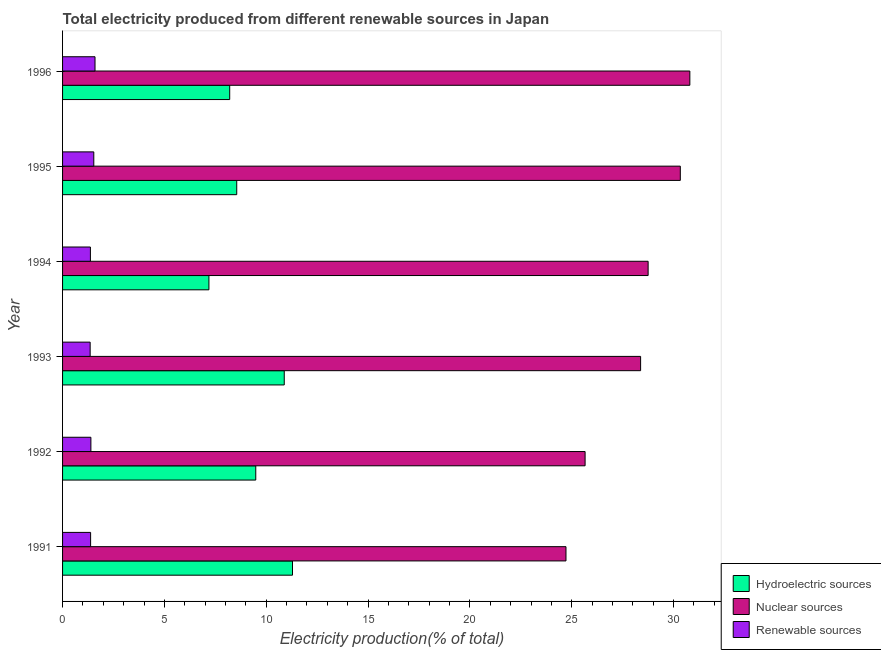How many different coloured bars are there?
Your response must be concise. 3. How many groups of bars are there?
Your response must be concise. 6. What is the label of the 4th group of bars from the top?
Keep it short and to the point. 1993. What is the percentage of electricity produced by hydroelectric sources in 1996?
Your answer should be compact. 8.21. Across all years, what is the maximum percentage of electricity produced by renewable sources?
Provide a short and direct response. 1.59. Across all years, what is the minimum percentage of electricity produced by nuclear sources?
Offer a terse response. 24.72. What is the total percentage of electricity produced by nuclear sources in the graph?
Your answer should be compact. 168.63. What is the difference between the percentage of electricity produced by renewable sources in 1992 and that in 1994?
Your answer should be compact. 0.02. What is the difference between the percentage of electricity produced by nuclear sources in 1996 and the percentage of electricity produced by hydroelectric sources in 1994?
Keep it short and to the point. 23.61. What is the average percentage of electricity produced by renewable sources per year?
Keep it short and to the point. 1.44. In the year 1996, what is the difference between the percentage of electricity produced by renewable sources and percentage of electricity produced by nuclear sources?
Ensure brevity in your answer.  -29.2. What is the ratio of the percentage of electricity produced by hydroelectric sources in 1994 to that in 1996?
Ensure brevity in your answer.  0.88. Is the percentage of electricity produced by hydroelectric sources in 1992 less than that in 1994?
Offer a very short reply. No. Is the difference between the percentage of electricity produced by hydroelectric sources in 1993 and 1996 greater than the difference between the percentage of electricity produced by nuclear sources in 1993 and 1996?
Your answer should be very brief. Yes. What is the difference between the highest and the second highest percentage of electricity produced by hydroelectric sources?
Provide a succinct answer. 0.41. In how many years, is the percentage of electricity produced by hydroelectric sources greater than the average percentage of electricity produced by hydroelectric sources taken over all years?
Provide a short and direct response. 3. Is the sum of the percentage of electricity produced by nuclear sources in 1993 and 1995 greater than the maximum percentage of electricity produced by renewable sources across all years?
Your response must be concise. Yes. What does the 3rd bar from the top in 1993 represents?
Your answer should be compact. Hydroelectric sources. What does the 1st bar from the bottom in 1995 represents?
Keep it short and to the point. Hydroelectric sources. Is it the case that in every year, the sum of the percentage of electricity produced by hydroelectric sources and percentage of electricity produced by nuclear sources is greater than the percentage of electricity produced by renewable sources?
Your answer should be compact. Yes. How many bars are there?
Make the answer very short. 18. Are all the bars in the graph horizontal?
Provide a short and direct response. Yes. What is the difference between two consecutive major ticks on the X-axis?
Keep it short and to the point. 5. Are the values on the major ticks of X-axis written in scientific E-notation?
Ensure brevity in your answer.  No. Does the graph contain any zero values?
Your response must be concise. No. Does the graph contain grids?
Offer a terse response. No. Where does the legend appear in the graph?
Give a very brief answer. Bottom right. How are the legend labels stacked?
Your response must be concise. Vertical. What is the title of the graph?
Your response must be concise. Total electricity produced from different renewable sources in Japan. What is the label or title of the X-axis?
Make the answer very short. Electricity production(% of total). What is the Electricity production(% of total) of Hydroelectric sources in 1991?
Your response must be concise. 11.29. What is the Electricity production(% of total) in Nuclear sources in 1991?
Your response must be concise. 24.72. What is the Electricity production(% of total) of Renewable sources in 1991?
Make the answer very short. 1.38. What is the Electricity production(% of total) of Hydroelectric sources in 1992?
Your response must be concise. 9.49. What is the Electricity production(% of total) of Nuclear sources in 1992?
Your answer should be compact. 25.65. What is the Electricity production(% of total) in Renewable sources in 1992?
Keep it short and to the point. 1.39. What is the Electricity production(% of total) of Hydroelectric sources in 1993?
Ensure brevity in your answer.  10.88. What is the Electricity production(% of total) of Nuclear sources in 1993?
Keep it short and to the point. 28.38. What is the Electricity production(% of total) of Renewable sources in 1993?
Offer a terse response. 1.35. What is the Electricity production(% of total) in Hydroelectric sources in 1994?
Your response must be concise. 7.19. What is the Electricity production(% of total) of Nuclear sources in 1994?
Keep it short and to the point. 28.75. What is the Electricity production(% of total) in Renewable sources in 1994?
Provide a short and direct response. 1.37. What is the Electricity production(% of total) of Hydroelectric sources in 1995?
Offer a terse response. 8.55. What is the Electricity production(% of total) of Nuclear sources in 1995?
Offer a terse response. 30.33. What is the Electricity production(% of total) in Renewable sources in 1995?
Ensure brevity in your answer.  1.53. What is the Electricity production(% of total) in Hydroelectric sources in 1996?
Provide a short and direct response. 8.21. What is the Electricity production(% of total) of Nuclear sources in 1996?
Give a very brief answer. 30.8. What is the Electricity production(% of total) of Renewable sources in 1996?
Your answer should be compact. 1.59. Across all years, what is the maximum Electricity production(% of total) in Hydroelectric sources?
Offer a very short reply. 11.29. Across all years, what is the maximum Electricity production(% of total) in Nuclear sources?
Provide a succinct answer. 30.8. Across all years, what is the maximum Electricity production(% of total) in Renewable sources?
Your answer should be very brief. 1.59. Across all years, what is the minimum Electricity production(% of total) of Hydroelectric sources?
Offer a very short reply. 7.19. Across all years, what is the minimum Electricity production(% of total) of Nuclear sources?
Provide a short and direct response. 24.72. Across all years, what is the minimum Electricity production(% of total) in Renewable sources?
Your answer should be compact. 1.35. What is the total Electricity production(% of total) of Hydroelectric sources in the graph?
Your response must be concise. 55.6. What is the total Electricity production(% of total) of Nuclear sources in the graph?
Offer a very short reply. 168.63. What is the total Electricity production(% of total) of Renewable sources in the graph?
Offer a very short reply. 8.62. What is the difference between the Electricity production(% of total) in Hydroelectric sources in 1991 and that in 1992?
Your answer should be compact. 1.8. What is the difference between the Electricity production(% of total) in Nuclear sources in 1991 and that in 1992?
Provide a succinct answer. -0.94. What is the difference between the Electricity production(% of total) of Renewable sources in 1991 and that in 1992?
Ensure brevity in your answer.  -0.01. What is the difference between the Electricity production(% of total) of Hydroelectric sources in 1991 and that in 1993?
Keep it short and to the point. 0.41. What is the difference between the Electricity production(% of total) in Nuclear sources in 1991 and that in 1993?
Make the answer very short. -3.66. What is the difference between the Electricity production(% of total) of Renewable sources in 1991 and that in 1993?
Provide a short and direct response. 0.02. What is the difference between the Electricity production(% of total) in Hydroelectric sources in 1991 and that in 1994?
Keep it short and to the point. 4.1. What is the difference between the Electricity production(% of total) in Nuclear sources in 1991 and that in 1994?
Offer a very short reply. -4.03. What is the difference between the Electricity production(% of total) in Renewable sources in 1991 and that in 1994?
Provide a short and direct response. 0.01. What is the difference between the Electricity production(% of total) of Hydroelectric sources in 1991 and that in 1995?
Your response must be concise. 2.74. What is the difference between the Electricity production(% of total) in Nuclear sources in 1991 and that in 1995?
Provide a short and direct response. -5.61. What is the difference between the Electricity production(% of total) in Renewable sources in 1991 and that in 1995?
Keep it short and to the point. -0.16. What is the difference between the Electricity production(% of total) of Hydroelectric sources in 1991 and that in 1996?
Your answer should be compact. 3.08. What is the difference between the Electricity production(% of total) in Nuclear sources in 1991 and that in 1996?
Give a very brief answer. -6.08. What is the difference between the Electricity production(% of total) of Renewable sources in 1991 and that in 1996?
Provide a short and direct response. -0.22. What is the difference between the Electricity production(% of total) of Hydroelectric sources in 1992 and that in 1993?
Ensure brevity in your answer.  -1.4. What is the difference between the Electricity production(% of total) of Nuclear sources in 1992 and that in 1993?
Your answer should be very brief. -2.73. What is the difference between the Electricity production(% of total) in Renewable sources in 1992 and that in 1993?
Ensure brevity in your answer.  0.04. What is the difference between the Electricity production(% of total) in Hydroelectric sources in 1992 and that in 1994?
Ensure brevity in your answer.  2.3. What is the difference between the Electricity production(% of total) of Nuclear sources in 1992 and that in 1994?
Your answer should be very brief. -3.09. What is the difference between the Electricity production(% of total) of Renewable sources in 1992 and that in 1994?
Make the answer very short. 0.02. What is the difference between the Electricity production(% of total) in Hydroelectric sources in 1992 and that in 1995?
Make the answer very short. 0.93. What is the difference between the Electricity production(% of total) of Nuclear sources in 1992 and that in 1995?
Give a very brief answer. -4.67. What is the difference between the Electricity production(% of total) in Renewable sources in 1992 and that in 1995?
Offer a very short reply. -0.14. What is the difference between the Electricity production(% of total) of Hydroelectric sources in 1992 and that in 1996?
Make the answer very short. 1.28. What is the difference between the Electricity production(% of total) of Nuclear sources in 1992 and that in 1996?
Offer a very short reply. -5.14. What is the difference between the Electricity production(% of total) of Renewable sources in 1992 and that in 1996?
Provide a short and direct response. -0.2. What is the difference between the Electricity production(% of total) in Hydroelectric sources in 1993 and that in 1994?
Make the answer very short. 3.7. What is the difference between the Electricity production(% of total) of Nuclear sources in 1993 and that in 1994?
Offer a terse response. -0.37. What is the difference between the Electricity production(% of total) of Renewable sources in 1993 and that in 1994?
Your answer should be very brief. -0.01. What is the difference between the Electricity production(% of total) of Hydroelectric sources in 1993 and that in 1995?
Your answer should be very brief. 2.33. What is the difference between the Electricity production(% of total) in Nuclear sources in 1993 and that in 1995?
Offer a terse response. -1.95. What is the difference between the Electricity production(% of total) of Renewable sources in 1993 and that in 1995?
Your answer should be very brief. -0.18. What is the difference between the Electricity production(% of total) of Hydroelectric sources in 1993 and that in 1996?
Ensure brevity in your answer.  2.68. What is the difference between the Electricity production(% of total) of Nuclear sources in 1993 and that in 1996?
Make the answer very short. -2.42. What is the difference between the Electricity production(% of total) of Renewable sources in 1993 and that in 1996?
Offer a very short reply. -0.24. What is the difference between the Electricity production(% of total) in Hydroelectric sources in 1994 and that in 1995?
Your answer should be compact. -1.37. What is the difference between the Electricity production(% of total) of Nuclear sources in 1994 and that in 1995?
Your answer should be very brief. -1.58. What is the difference between the Electricity production(% of total) of Renewable sources in 1994 and that in 1995?
Provide a succinct answer. -0.17. What is the difference between the Electricity production(% of total) in Hydroelectric sources in 1994 and that in 1996?
Keep it short and to the point. -1.02. What is the difference between the Electricity production(% of total) of Nuclear sources in 1994 and that in 1996?
Your answer should be compact. -2.05. What is the difference between the Electricity production(% of total) of Renewable sources in 1994 and that in 1996?
Ensure brevity in your answer.  -0.23. What is the difference between the Electricity production(% of total) of Hydroelectric sources in 1995 and that in 1996?
Your response must be concise. 0.35. What is the difference between the Electricity production(% of total) in Nuclear sources in 1995 and that in 1996?
Make the answer very short. -0.47. What is the difference between the Electricity production(% of total) of Renewable sources in 1995 and that in 1996?
Offer a very short reply. -0.06. What is the difference between the Electricity production(% of total) of Hydroelectric sources in 1991 and the Electricity production(% of total) of Nuclear sources in 1992?
Make the answer very short. -14.37. What is the difference between the Electricity production(% of total) in Hydroelectric sources in 1991 and the Electricity production(% of total) in Renewable sources in 1992?
Your answer should be compact. 9.9. What is the difference between the Electricity production(% of total) of Nuclear sources in 1991 and the Electricity production(% of total) of Renewable sources in 1992?
Give a very brief answer. 23.33. What is the difference between the Electricity production(% of total) of Hydroelectric sources in 1991 and the Electricity production(% of total) of Nuclear sources in 1993?
Provide a short and direct response. -17.09. What is the difference between the Electricity production(% of total) in Hydroelectric sources in 1991 and the Electricity production(% of total) in Renewable sources in 1993?
Make the answer very short. 9.93. What is the difference between the Electricity production(% of total) of Nuclear sources in 1991 and the Electricity production(% of total) of Renewable sources in 1993?
Make the answer very short. 23.36. What is the difference between the Electricity production(% of total) of Hydroelectric sources in 1991 and the Electricity production(% of total) of Nuclear sources in 1994?
Keep it short and to the point. -17.46. What is the difference between the Electricity production(% of total) in Hydroelectric sources in 1991 and the Electricity production(% of total) in Renewable sources in 1994?
Make the answer very short. 9.92. What is the difference between the Electricity production(% of total) of Nuclear sources in 1991 and the Electricity production(% of total) of Renewable sources in 1994?
Your answer should be very brief. 23.35. What is the difference between the Electricity production(% of total) in Hydroelectric sources in 1991 and the Electricity production(% of total) in Nuclear sources in 1995?
Ensure brevity in your answer.  -19.04. What is the difference between the Electricity production(% of total) of Hydroelectric sources in 1991 and the Electricity production(% of total) of Renewable sources in 1995?
Ensure brevity in your answer.  9.76. What is the difference between the Electricity production(% of total) of Nuclear sources in 1991 and the Electricity production(% of total) of Renewable sources in 1995?
Your answer should be compact. 23.18. What is the difference between the Electricity production(% of total) in Hydroelectric sources in 1991 and the Electricity production(% of total) in Nuclear sources in 1996?
Your answer should be compact. -19.51. What is the difference between the Electricity production(% of total) in Hydroelectric sources in 1991 and the Electricity production(% of total) in Renewable sources in 1996?
Provide a short and direct response. 9.7. What is the difference between the Electricity production(% of total) in Nuclear sources in 1991 and the Electricity production(% of total) in Renewable sources in 1996?
Make the answer very short. 23.12. What is the difference between the Electricity production(% of total) of Hydroelectric sources in 1992 and the Electricity production(% of total) of Nuclear sources in 1993?
Your answer should be compact. -18.89. What is the difference between the Electricity production(% of total) of Hydroelectric sources in 1992 and the Electricity production(% of total) of Renewable sources in 1993?
Give a very brief answer. 8.13. What is the difference between the Electricity production(% of total) of Nuclear sources in 1992 and the Electricity production(% of total) of Renewable sources in 1993?
Your answer should be very brief. 24.3. What is the difference between the Electricity production(% of total) of Hydroelectric sources in 1992 and the Electricity production(% of total) of Nuclear sources in 1994?
Provide a short and direct response. -19.26. What is the difference between the Electricity production(% of total) of Hydroelectric sources in 1992 and the Electricity production(% of total) of Renewable sources in 1994?
Give a very brief answer. 8.12. What is the difference between the Electricity production(% of total) of Nuclear sources in 1992 and the Electricity production(% of total) of Renewable sources in 1994?
Ensure brevity in your answer.  24.29. What is the difference between the Electricity production(% of total) in Hydroelectric sources in 1992 and the Electricity production(% of total) in Nuclear sources in 1995?
Keep it short and to the point. -20.84. What is the difference between the Electricity production(% of total) in Hydroelectric sources in 1992 and the Electricity production(% of total) in Renewable sources in 1995?
Your answer should be compact. 7.95. What is the difference between the Electricity production(% of total) in Nuclear sources in 1992 and the Electricity production(% of total) in Renewable sources in 1995?
Your answer should be very brief. 24.12. What is the difference between the Electricity production(% of total) in Hydroelectric sources in 1992 and the Electricity production(% of total) in Nuclear sources in 1996?
Ensure brevity in your answer.  -21.31. What is the difference between the Electricity production(% of total) of Hydroelectric sources in 1992 and the Electricity production(% of total) of Renewable sources in 1996?
Ensure brevity in your answer.  7.89. What is the difference between the Electricity production(% of total) of Nuclear sources in 1992 and the Electricity production(% of total) of Renewable sources in 1996?
Your response must be concise. 24.06. What is the difference between the Electricity production(% of total) in Hydroelectric sources in 1993 and the Electricity production(% of total) in Nuclear sources in 1994?
Offer a very short reply. -17.87. What is the difference between the Electricity production(% of total) of Hydroelectric sources in 1993 and the Electricity production(% of total) of Renewable sources in 1994?
Offer a terse response. 9.52. What is the difference between the Electricity production(% of total) of Nuclear sources in 1993 and the Electricity production(% of total) of Renewable sources in 1994?
Provide a succinct answer. 27.01. What is the difference between the Electricity production(% of total) of Hydroelectric sources in 1993 and the Electricity production(% of total) of Nuclear sources in 1995?
Offer a very short reply. -19.45. What is the difference between the Electricity production(% of total) in Hydroelectric sources in 1993 and the Electricity production(% of total) in Renewable sources in 1995?
Ensure brevity in your answer.  9.35. What is the difference between the Electricity production(% of total) of Nuclear sources in 1993 and the Electricity production(% of total) of Renewable sources in 1995?
Your answer should be compact. 26.85. What is the difference between the Electricity production(% of total) in Hydroelectric sources in 1993 and the Electricity production(% of total) in Nuclear sources in 1996?
Your answer should be compact. -19.91. What is the difference between the Electricity production(% of total) of Hydroelectric sources in 1993 and the Electricity production(% of total) of Renewable sources in 1996?
Your response must be concise. 9.29. What is the difference between the Electricity production(% of total) of Nuclear sources in 1993 and the Electricity production(% of total) of Renewable sources in 1996?
Ensure brevity in your answer.  26.79. What is the difference between the Electricity production(% of total) in Hydroelectric sources in 1994 and the Electricity production(% of total) in Nuclear sources in 1995?
Your answer should be compact. -23.14. What is the difference between the Electricity production(% of total) of Hydroelectric sources in 1994 and the Electricity production(% of total) of Renewable sources in 1995?
Provide a succinct answer. 5.65. What is the difference between the Electricity production(% of total) of Nuclear sources in 1994 and the Electricity production(% of total) of Renewable sources in 1995?
Your response must be concise. 27.22. What is the difference between the Electricity production(% of total) of Hydroelectric sources in 1994 and the Electricity production(% of total) of Nuclear sources in 1996?
Your answer should be very brief. -23.61. What is the difference between the Electricity production(% of total) in Hydroelectric sources in 1994 and the Electricity production(% of total) in Renewable sources in 1996?
Keep it short and to the point. 5.59. What is the difference between the Electricity production(% of total) in Nuclear sources in 1994 and the Electricity production(% of total) in Renewable sources in 1996?
Offer a terse response. 27.16. What is the difference between the Electricity production(% of total) of Hydroelectric sources in 1995 and the Electricity production(% of total) of Nuclear sources in 1996?
Give a very brief answer. -22.25. What is the difference between the Electricity production(% of total) in Hydroelectric sources in 1995 and the Electricity production(% of total) in Renewable sources in 1996?
Ensure brevity in your answer.  6.96. What is the difference between the Electricity production(% of total) of Nuclear sources in 1995 and the Electricity production(% of total) of Renewable sources in 1996?
Make the answer very short. 28.74. What is the average Electricity production(% of total) in Hydroelectric sources per year?
Offer a very short reply. 9.27. What is the average Electricity production(% of total) in Nuclear sources per year?
Provide a short and direct response. 28.1. What is the average Electricity production(% of total) in Renewable sources per year?
Your answer should be very brief. 1.44. In the year 1991, what is the difference between the Electricity production(% of total) of Hydroelectric sources and Electricity production(% of total) of Nuclear sources?
Offer a very short reply. -13.43. In the year 1991, what is the difference between the Electricity production(% of total) in Hydroelectric sources and Electricity production(% of total) in Renewable sources?
Your response must be concise. 9.91. In the year 1991, what is the difference between the Electricity production(% of total) of Nuclear sources and Electricity production(% of total) of Renewable sources?
Provide a short and direct response. 23.34. In the year 1992, what is the difference between the Electricity production(% of total) in Hydroelectric sources and Electricity production(% of total) in Nuclear sources?
Make the answer very short. -16.17. In the year 1992, what is the difference between the Electricity production(% of total) of Hydroelectric sources and Electricity production(% of total) of Renewable sources?
Make the answer very short. 8.09. In the year 1992, what is the difference between the Electricity production(% of total) of Nuclear sources and Electricity production(% of total) of Renewable sources?
Offer a terse response. 24.26. In the year 1993, what is the difference between the Electricity production(% of total) of Hydroelectric sources and Electricity production(% of total) of Nuclear sources?
Your answer should be compact. -17.5. In the year 1993, what is the difference between the Electricity production(% of total) in Hydroelectric sources and Electricity production(% of total) in Renewable sources?
Provide a succinct answer. 9.53. In the year 1993, what is the difference between the Electricity production(% of total) in Nuclear sources and Electricity production(% of total) in Renewable sources?
Give a very brief answer. 27.03. In the year 1994, what is the difference between the Electricity production(% of total) of Hydroelectric sources and Electricity production(% of total) of Nuclear sources?
Provide a succinct answer. -21.56. In the year 1994, what is the difference between the Electricity production(% of total) in Hydroelectric sources and Electricity production(% of total) in Renewable sources?
Your answer should be very brief. 5.82. In the year 1994, what is the difference between the Electricity production(% of total) of Nuclear sources and Electricity production(% of total) of Renewable sources?
Provide a short and direct response. 27.38. In the year 1995, what is the difference between the Electricity production(% of total) in Hydroelectric sources and Electricity production(% of total) in Nuclear sources?
Your answer should be compact. -21.78. In the year 1995, what is the difference between the Electricity production(% of total) in Hydroelectric sources and Electricity production(% of total) in Renewable sources?
Keep it short and to the point. 7.02. In the year 1995, what is the difference between the Electricity production(% of total) of Nuclear sources and Electricity production(% of total) of Renewable sources?
Offer a very short reply. 28.8. In the year 1996, what is the difference between the Electricity production(% of total) in Hydroelectric sources and Electricity production(% of total) in Nuclear sources?
Provide a short and direct response. -22.59. In the year 1996, what is the difference between the Electricity production(% of total) of Hydroelectric sources and Electricity production(% of total) of Renewable sources?
Your response must be concise. 6.61. In the year 1996, what is the difference between the Electricity production(% of total) in Nuclear sources and Electricity production(% of total) in Renewable sources?
Ensure brevity in your answer.  29.2. What is the ratio of the Electricity production(% of total) of Hydroelectric sources in 1991 to that in 1992?
Your response must be concise. 1.19. What is the ratio of the Electricity production(% of total) of Nuclear sources in 1991 to that in 1992?
Your answer should be very brief. 0.96. What is the ratio of the Electricity production(% of total) in Hydroelectric sources in 1991 to that in 1993?
Offer a terse response. 1.04. What is the ratio of the Electricity production(% of total) in Nuclear sources in 1991 to that in 1993?
Provide a succinct answer. 0.87. What is the ratio of the Electricity production(% of total) in Renewable sources in 1991 to that in 1993?
Ensure brevity in your answer.  1.02. What is the ratio of the Electricity production(% of total) in Hydroelectric sources in 1991 to that in 1994?
Ensure brevity in your answer.  1.57. What is the ratio of the Electricity production(% of total) of Nuclear sources in 1991 to that in 1994?
Your answer should be very brief. 0.86. What is the ratio of the Electricity production(% of total) of Renewable sources in 1991 to that in 1994?
Ensure brevity in your answer.  1.01. What is the ratio of the Electricity production(% of total) of Hydroelectric sources in 1991 to that in 1995?
Give a very brief answer. 1.32. What is the ratio of the Electricity production(% of total) in Nuclear sources in 1991 to that in 1995?
Provide a succinct answer. 0.81. What is the ratio of the Electricity production(% of total) in Renewable sources in 1991 to that in 1995?
Your answer should be compact. 0.9. What is the ratio of the Electricity production(% of total) of Hydroelectric sources in 1991 to that in 1996?
Your response must be concise. 1.38. What is the ratio of the Electricity production(% of total) in Nuclear sources in 1991 to that in 1996?
Make the answer very short. 0.8. What is the ratio of the Electricity production(% of total) of Renewable sources in 1991 to that in 1996?
Keep it short and to the point. 0.86. What is the ratio of the Electricity production(% of total) in Hydroelectric sources in 1992 to that in 1993?
Keep it short and to the point. 0.87. What is the ratio of the Electricity production(% of total) of Nuclear sources in 1992 to that in 1993?
Offer a terse response. 0.9. What is the ratio of the Electricity production(% of total) of Renewable sources in 1992 to that in 1993?
Offer a very short reply. 1.03. What is the ratio of the Electricity production(% of total) in Hydroelectric sources in 1992 to that in 1994?
Your answer should be very brief. 1.32. What is the ratio of the Electricity production(% of total) in Nuclear sources in 1992 to that in 1994?
Keep it short and to the point. 0.89. What is the ratio of the Electricity production(% of total) of Renewable sources in 1992 to that in 1994?
Your answer should be very brief. 1.02. What is the ratio of the Electricity production(% of total) in Hydroelectric sources in 1992 to that in 1995?
Your response must be concise. 1.11. What is the ratio of the Electricity production(% of total) of Nuclear sources in 1992 to that in 1995?
Offer a very short reply. 0.85. What is the ratio of the Electricity production(% of total) of Renewable sources in 1992 to that in 1995?
Provide a short and direct response. 0.91. What is the ratio of the Electricity production(% of total) of Hydroelectric sources in 1992 to that in 1996?
Provide a succinct answer. 1.16. What is the ratio of the Electricity production(% of total) of Nuclear sources in 1992 to that in 1996?
Your answer should be very brief. 0.83. What is the ratio of the Electricity production(% of total) in Renewable sources in 1992 to that in 1996?
Provide a short and direct response. 0.87. What is the ratio of the Electricity production(% of total) of Hydroelectric sources in 1993 to that in 1994?
Offer a terse response. 1.51. What is the ratio of the Electricity production(% of total) in Nuclear sources in 1993 to that in 1994?
Give a very brief answer. 0.99. What is the ratio of the Electricity production(% of total) of Hydroelectric sources in 1993 to that in 1995?
Offer a terse response. 1.27. What is the ratio of the Electricity production(% of total) of Nuclear sources in 1993 to that in 1995?
Make the answer very short. 0.94. What is the ratio of the Electricity production(% of total) in Renewable sources in 1993 to that in 1995?
Ensure brevity in your answer.  0.88. What is the ratio of the Electricity production(% of total) of Hydroelectric sources in 1993 to that in 1996?
Offer a very short reply. 1.33. What is the ratio of the Electricity production(% of total) in Nuclear sources in 1993 to that in 1996?
Provide a succinct answer. 0.92. What is the ratio of the Electricity production(% of total) of Renewable sources in 1993 to that in 1996?
Keep it short and to the point. 0.85. What is the ratio of the Electricity production(% of total) in Hydroelectric sources in 1994 to that in 1995?
Offer a terse response. 0.84. What is the ratio of the Electricity production(% of total) in Nuclear sources in 1994 to that in 1995?
Ensure brevity in your answer.  0.95. What is the ratio of the Electricity production(% of total) of Renewable sources in 1994 to that in 1995?
Give a very brief answer. 0.89. What is the ratio of the Electricity production(% of total) of Hydroelectric sources in 1994 to that in 1996?
Your answer should be very brief. 0.88. What is the ratio of the Electricity production(% of total) of Nuclear sources in 1994 to that in 1996?
Your answer should be very brief. 0.93. What is the ratio of the Electricity production(% of total) in Renewable sources in 1994 to that in 1996?
Make the answer very short. 0.86. What is the ratio of the Electricity production(% of total) of Hydroelectric sources in 1995 to that in 1996?
Offer a terse response. 1.04. What is the ratio of the Electricity production(% of total) in Renewable sources in 1995 to that in 1996?
Give a very brief answer. 0.96. What is the difference between the highest and the second highest Electricity production(% of total) in Hydroelectric sources?
Your response must be concise. 0.41. What is the difference between the highest and the second highest Electricity production(% of total) in Nuclear sources?
Your answer should be compact. 0.47. What is the difference between the highest and the second highest Electricity production(% of total) in Renewable sources?
Make the answer very short. 0.06. What is the difference between the highest and the lowest Electricity production(% of total) of Hydroelectric sources?
Provide a succinct answer. 4.1. What is the difference between the highest and the lowest Electricity production(% of total) of Nuclear sources?
Provide a succinct answer. 6.08. What is the difference between the highest and the lowest Electricity production(% of total) in Renewable sources?
Make the answer very short. 0.24. 